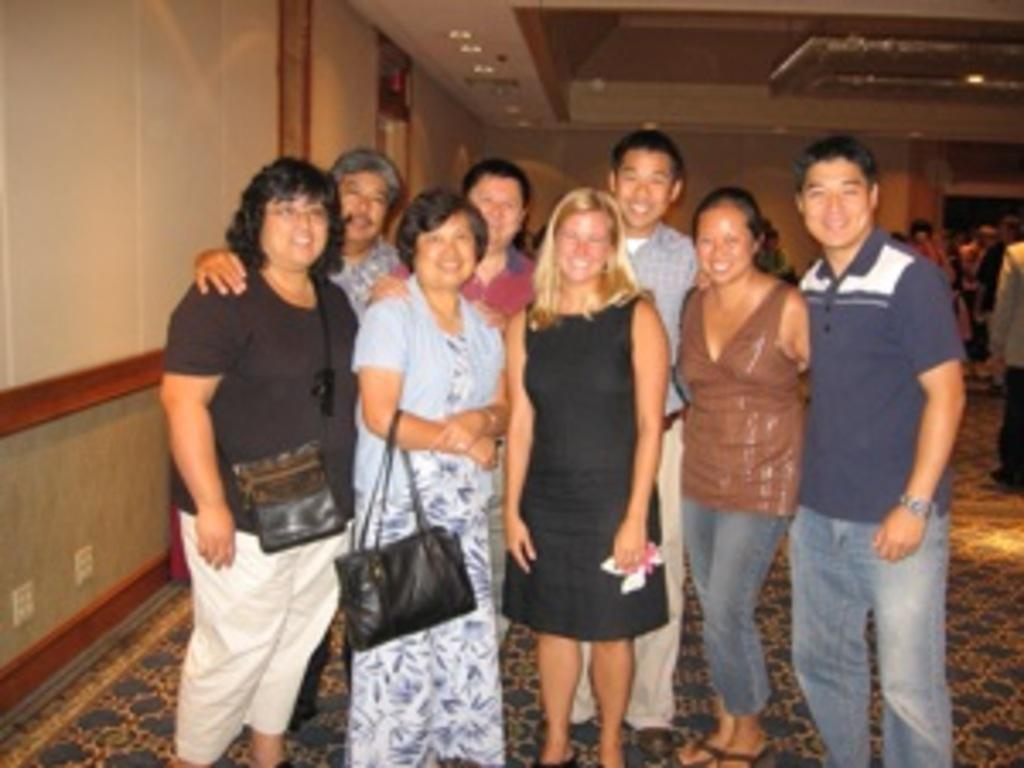What are the persons in the image doing? The persons in the image are posing to a camera. What is the facial expression of the persons in the image? The persons are smiling. What is on the floor in the image? There is a carpet on the floor in the image. Can you describe the background of the image? There are persons visible in the background of the image, and there is a wall in the background. What type of degree is the beast holding in the image? There is no beast or degree present in the image. 